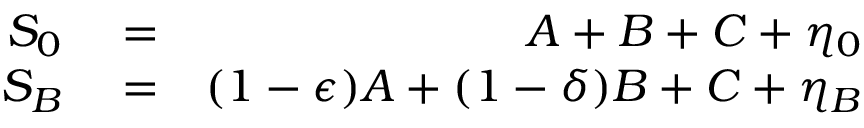<formula> <loc_0><loc_0><loc_500><loc_500>\begin{array} { r l r } { S _ { 0 } } & = } & { A + B + C + \eta _ { 0 } } \\ { S _ { B } } & = } & { ( 1 - \epsilon ) A + ( 1 - \delta ) B + C + \eta _ { B } } \end{array}</formula> 